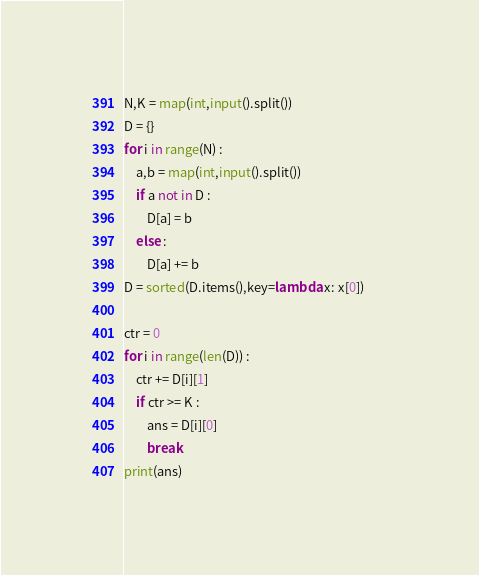<code> <loc_0><loc_0><loc_500><loc_500><_Python_>N,K = map(int,input().split())
D = {}
for i in range(N) :
    a,b = map(int,input().split())
    if a not in D :
        D[a] = b
    else :
        D[a] += b
D = sorted(D.items(),key=lambda x: x[0])        

ctr = 0
for i in range(len(D)) :
    ctr += D[i][1]
    if ctr >= K :
        ans = D[i][0]
        break
print(ans)
</code> 